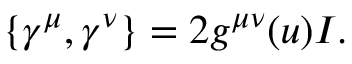<formula> <loc_0><loc_0><loc_500><loc_500>\{ \gamma ^ { \mu } , \gamma ^ { \nu } \} = 2 g ^ { \mu \nu } ( u ) I .</formula> 